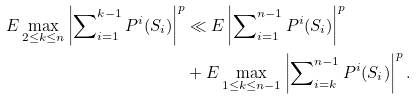Convert formula to latex. <formula><loc_0><loc_0><loc_500><loc_500>E \max _ { 2 \leq k \leq n } \left | \sum \nolimits _ { i = 1 } ^ { k - 1 } P ^ { i } ( S _ { i } ) \right | ^ { p } & \ll E \left | \sum \nolimits _ { i = 1 } ^ { n - 1 } P ^ { i } ( S _ { i } ) \right | ^ { p } \\ & + E \max _ { 1 \leq k \leq n - 1 } \left | \sum \nolimits _ { i = k } ^ { n - 1 } P ^ { i } ( S _ { i } ) \right | ^ { p } .</formula> 